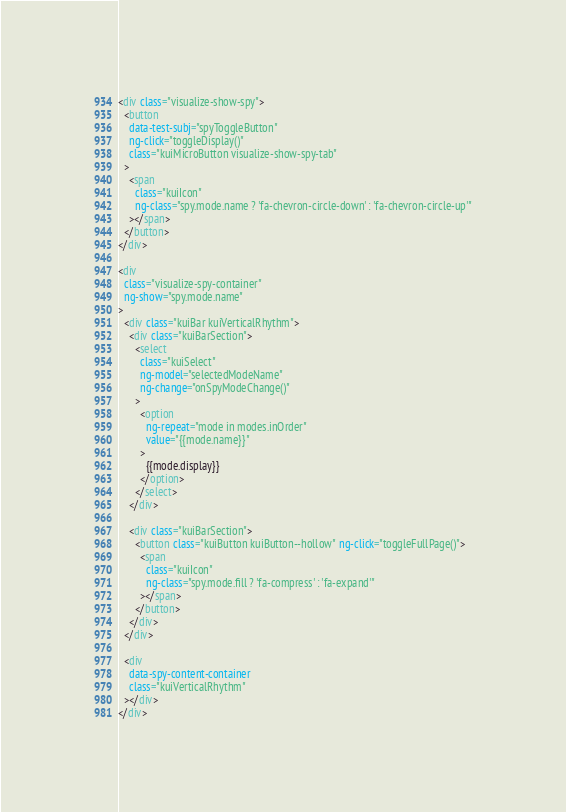<code> <loc_0><loc_0><loc_500><loc_500><_HTML_><div class="visualize-show-spy">
  <button
    data-test-subj="spyToggleButton"
    ng-click="toggleDisplay()"
    class="kuiMicroButton visualize-show-spy-tab"
  >
    <span
      class="kuiIcon"
      ng-class="spy.mode.name ? 'fa-chevron-circle-down' : 'fa-chevron-circle-up'"
    ></span>
  </button>
</div>

<div
  class="visualize-spy-container"
  ng-show="spy.mode.name"
>
  <div class="kuiBar kuiVerticalRhythm">
    <div class="kuiBarSection">
      <select
        class="kuiSelect"
        ng-model="selectedModeName"
        ng-change="onSpyModeChange()"
      >
        <option
          ng-repeat="mode in modes.inOrder"
          value="{{mode.name}}"
        >
          {{mode.display}}
        </option>
      </select>
    </div>

    <div class="kuiBarSection">
      <button class="kuiButton kuiButton--hollow" ng-click="toggleFullPage()">
        <span
          class="kuiIcon"
          ng-class="spy.mode.fill ? 'fa-compress' : 'fa-expand'"
        ></span>
      </button>
    </div>
  </div>

  <div
    data-spy-content-container
    class="kuiVerticalRhythm"
  ></div>
</div>
</code> 